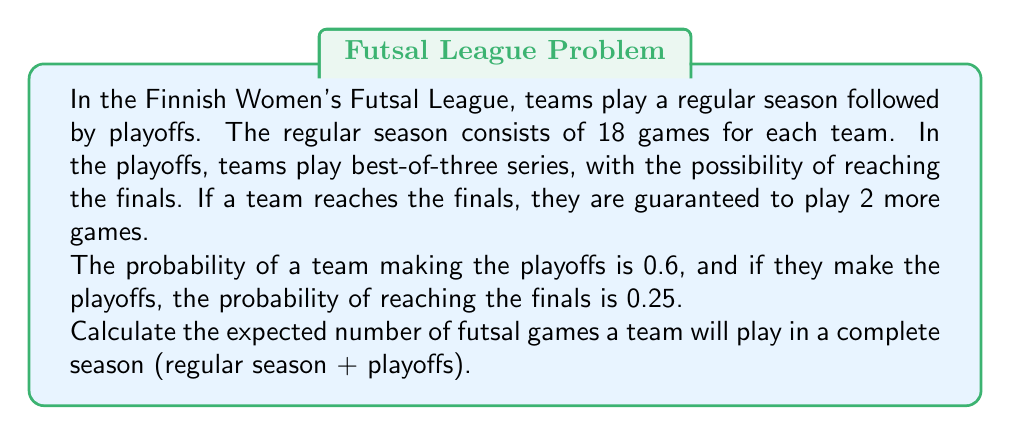Give your solution to this math problem. Let's break this down step-by-step:

1) First, we need to consider all possible scenarios:
   a) Not making playoffs
   b) Making playoffs but not reaching finals
   c) Making playoffs and reaching finals

2) For each scenario, we need to calculate:
   a) The probability of the scenario occurring
   b) The number of games played in that scenario

3) Scenario probabilities:
   a) Not making playoffs: $P(\text{No playoffs}) = 1 - 0.6 = 0.4$
   b) Making playoffs but not finals: $P(\text{Playoffs, no finals}) = 0.6 * (1 - 0.25) = 0.45$
   c) Making playoffs and finals: $P(\text{Playoffs and finals}) = 0.6 * 0.25 = 0.15$

4) Number of games in each scenario:
   a) Not making playoffs: 18 games
   b) Making playoffs but not finals: 18 + 2 or 3 games (average 2.5)
   c) Making playoffs and finals: 18 + 2 or 3 + 2 games (average 4.5)

5) Expected value calculation:
   $E(\text{Games}) = 18 * 0.4 + (18 + 2.5) * 0.45 + (18 + 4.5) * 0.15$

6) Simplifying:
   $E(\text{Games}) = 7.2 + 9.225 + 3.375 = 19.8$

Therefore, the expected number of games is 19.8.
Answer: 19.8 games 